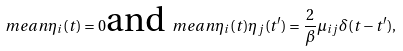Convert formula to latex. <formula><loc_0><loc_0><loc_500><loc_500>\ m e a n { \eta _ { i } ( t ) } = 0 \text {and} \ m e a n { \eta _ { i } ( t ) \eta _ { j } ( t ^ { \prime } ) } = \frac { 2 } { \beta } \mu _ { i j } \delta ( t - t ^ { \prime } ) ,</formula> 